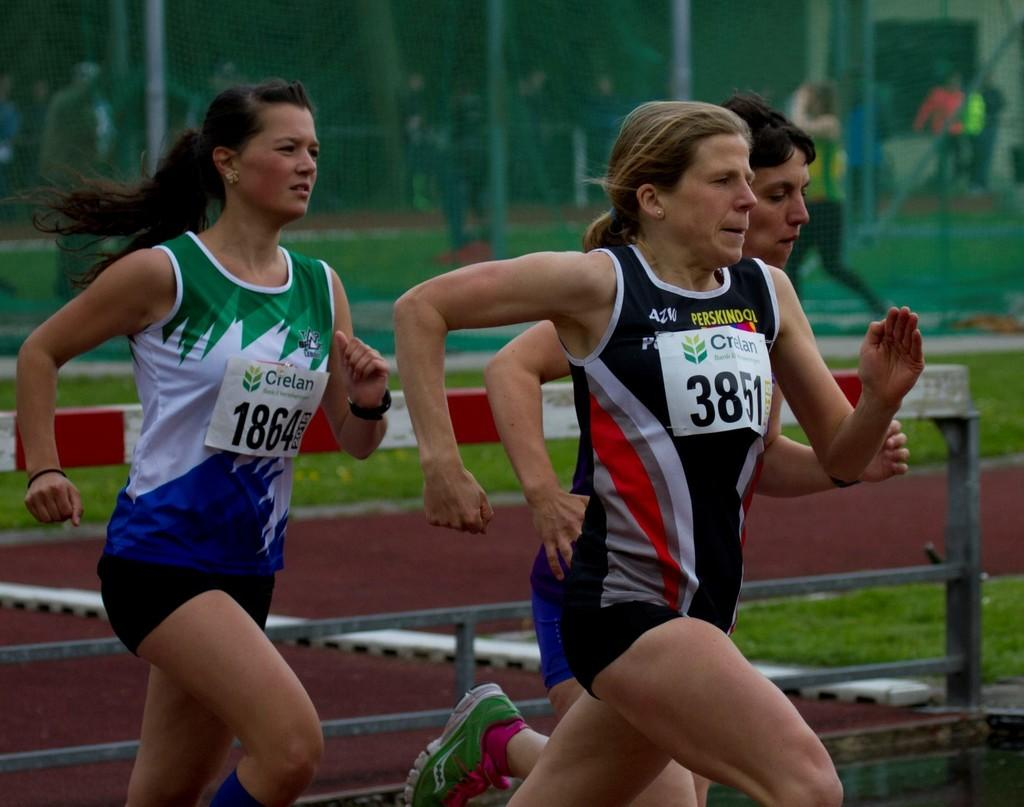<image>
Offer a succinct explanation of the picture presented. Woman running and wearing a sign which says 3851. 